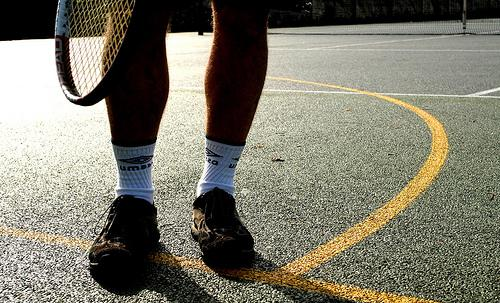Question: what do you see in the background?
Choices:
A. Net.
B. Trees.
C. Farm.
D. Forest.
Answer with the letter. Answer: A Question: what is he wearing?
Choices:
A. Shorts.
B. Jeans.
C. Uniform.
D. Sweatshirt.
Answer with the letter. Answer: A Question: why is he going to play tennis?
Choices:
A. Professional.
B. Good Exercise.
C. It's his job.
D. He's on a league.
Answer with the letter. Answer: B Question: what type of shoes does he have on?
Choices:
A. Sandals.
B. Flip flops.
C. Sneakers.
D. Tennis Shoes.
Answer with the letter. Answer: D Question: where is he going to play tennis?
Choices:
A. At the park.
B. At the school.
C. On Tennis Court.
D. In the gymnasium.
Answer with the letter. Answer: C Question: what game is he getting ready to play?
Choices:
A. Tennis.
B. Football.
C. Soccer.
D. Hockey.
Answer with the letter. Answer: A Question: what is he carrying?
Choices:
A. Tennis Racquet.
B. Gun.
C. Stick.
D. Bible.
Answer with the letter. Answer: A 